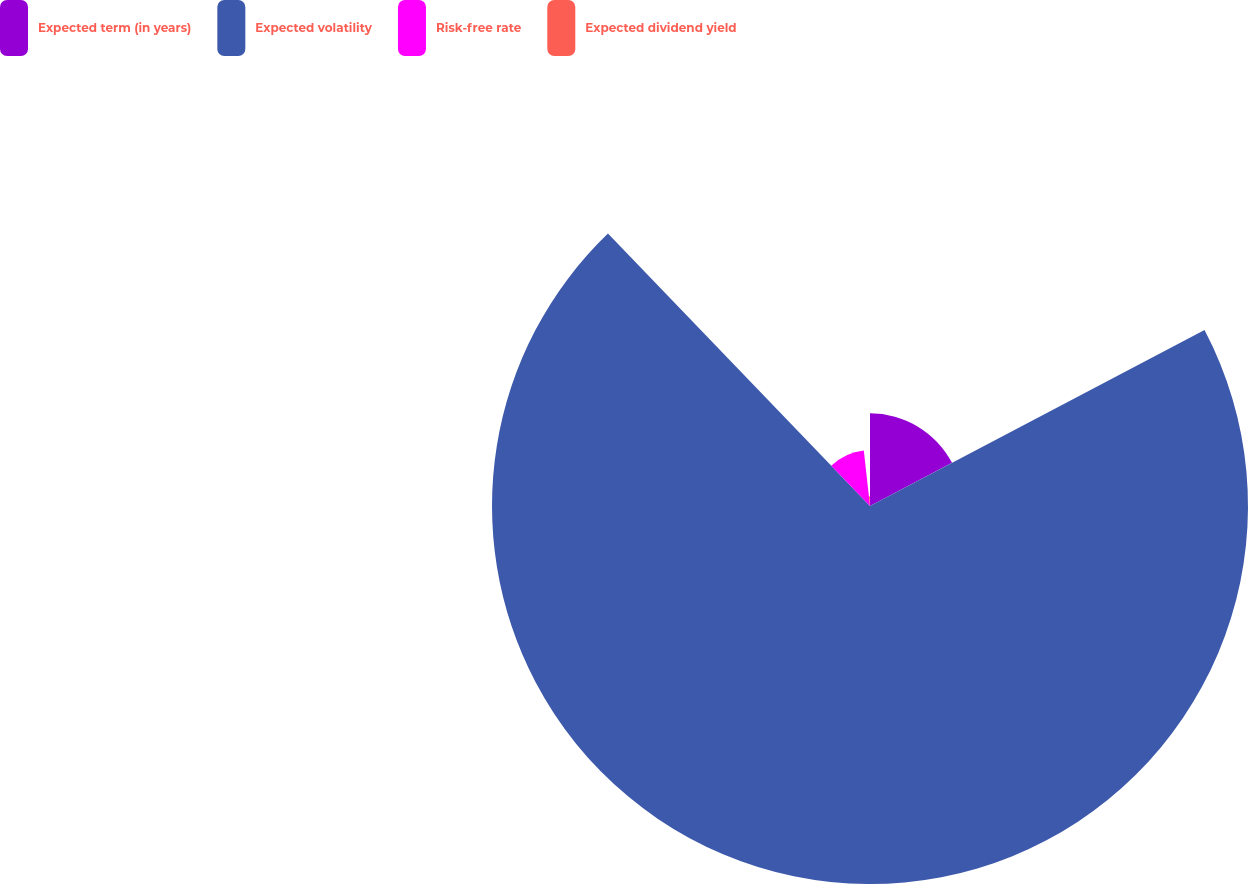<chart> <loc_0><loc_0><loc_500><loc_500><pie_chart><fcel>Expected term (in years)<fcel>Expected volatility<fcel>Risk-free rate<fcel>Expected dividend yield<nl><fcel>17.29%<fcel>70.51%<fcel>10.42%<fcel>1.77%<nl></chart> 